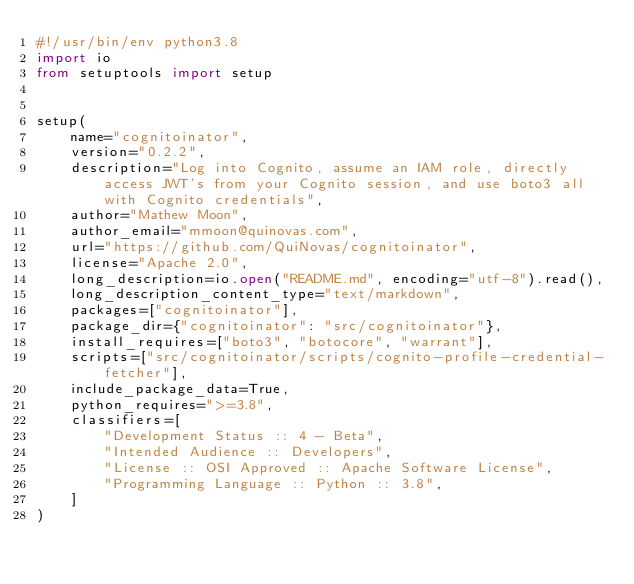Convert code to text. <code><loc_0><loc_0><loc_500><loc_500><_Python_>#!/usr/bin/env python3.8
import io
from setuptools import setup


setup(
    name="cognitoinator",
    version="0.2.2",
    description="Log into Cognito, assume an IAM role, directly access JWT's from your Cognito session, and use boto3 all with Cognito credentials",
    author="Mathew Moon",
    author_email="mmoon@quinovas.com",
    url="https://github.com/QuiNovas/cognitoinator",
    license="Apache 2.0",
    long_description=io.open("README.md", encoding="utf-8").read(),
    long_description_content_type="text/markdown",
    packages=["cognitoinator"],
    package_dir={"cognitoinator": "src/cognitoinator"},
    install_requires=["boto3", "botocore", "warrant"],
    scripts=["src/cognitoinator/scripts/cognito-profile-credential-fetcher"],
    include_package_data=True,
    python_requires=">=3.8",
    classifiers=[
        "Development Status :: 4 - Beta",
        "Intended Audience :: Developers",
        "License :: OSI Approved :: Apache Software License",
        "Programming Language :: Python :: 3.8",
    ]
)
</code> 